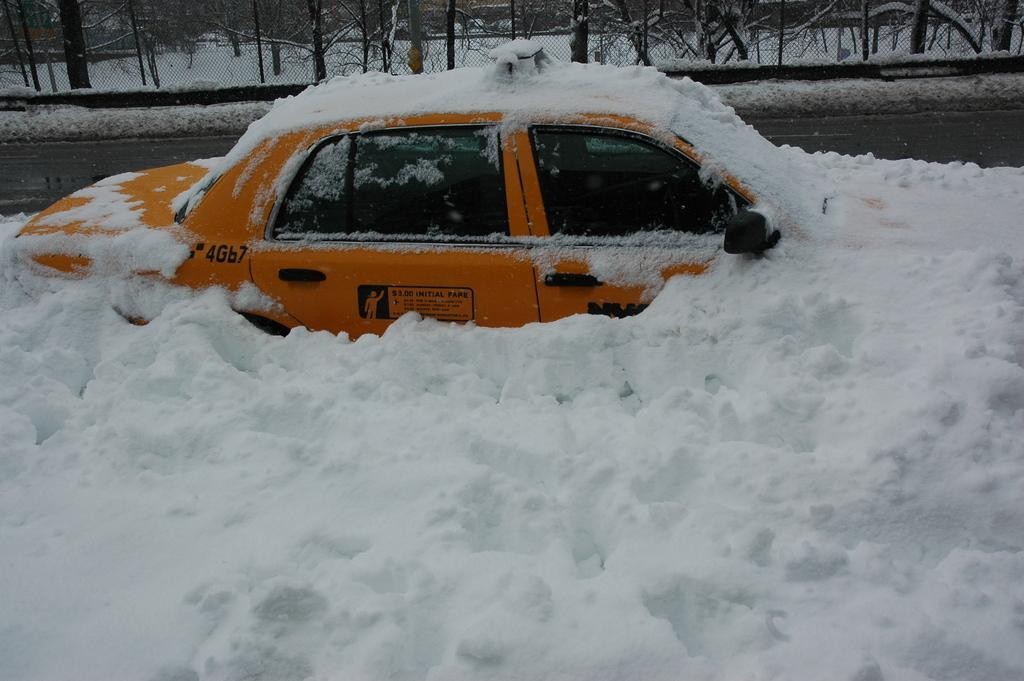What is the main subject of the image? The main subject of the image is a car. How is the car affected by the weather in the image? The car is covered with snow in the image. What is located behind the car? There is a fence behind the car. What can be seen in the distance in the image? Trees are visible in the background of the image. Can you see any goldfish swimming in the snow around the car? There are no goldfish present in the image; it features a car covered in snow with a fence and trees in the background. 